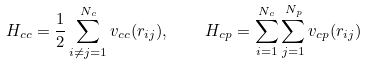<formula> <loc_0><loc_0><loc_500><loc_500>H _ { c c } = \frac { 1 } { 2 } \sum _ { i \neq j = 1 } ^ { N _ { c } } v _ { c c } ( r _ { i j } ) , \quad H _ { c p } = \sum _ { i = 1 } ^ { N _ { c } } \sum _ { j = 1 } ^ { N _ { p } } v _ { c p } ( r _ { i j } )</formula> 